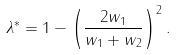<formula> <loc_0><loc_0><loc_500><loc_500>\lambda ^ { * } = 1 - \left ( \frac { 2 w _ { 1 } } { w _ { 1 } + w _ { 2 } } \right ) ^ { 2 } .</formula> 